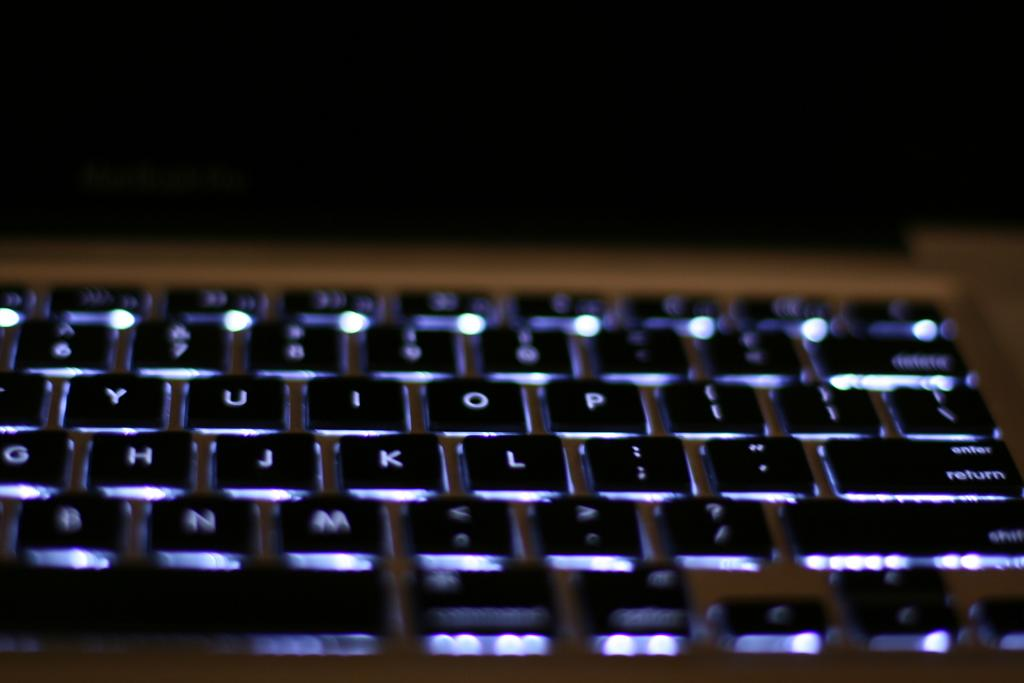<image>
Describe the image concisely. A closeup of a keyboard with the "return" key visible 